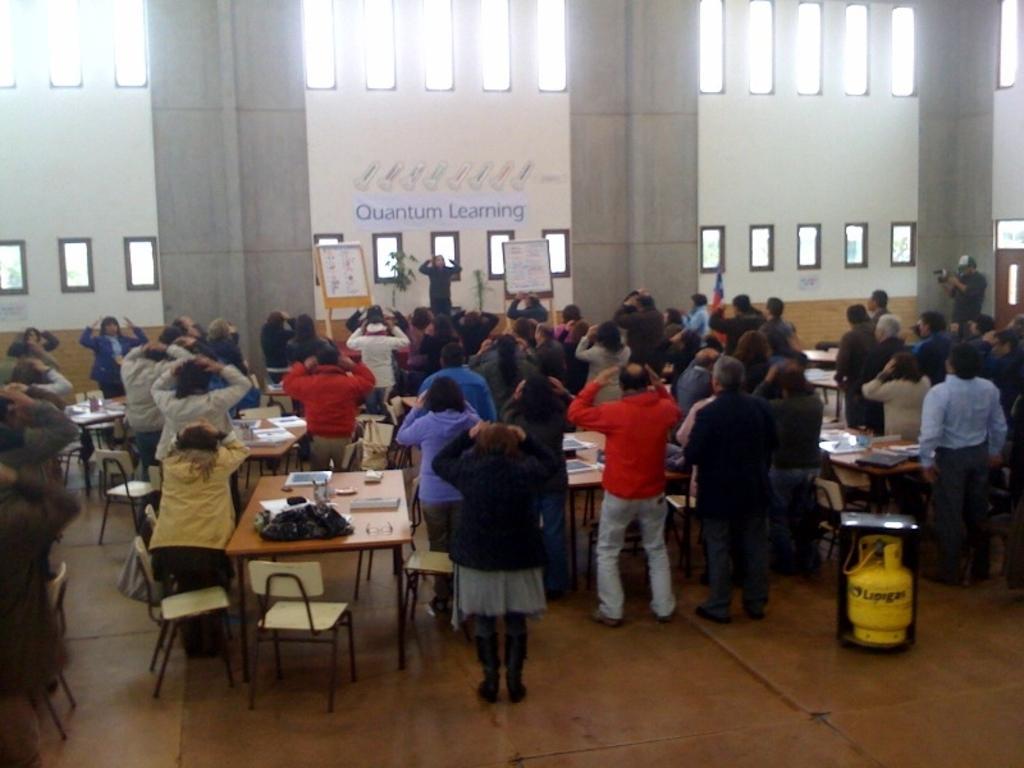How would you summarize this image in a sentence or two? In this image there are group of people standing near the chair, table and there is a cylinder, and in table there are bag , and the back ground there is pillar, board , plant ,name board. 